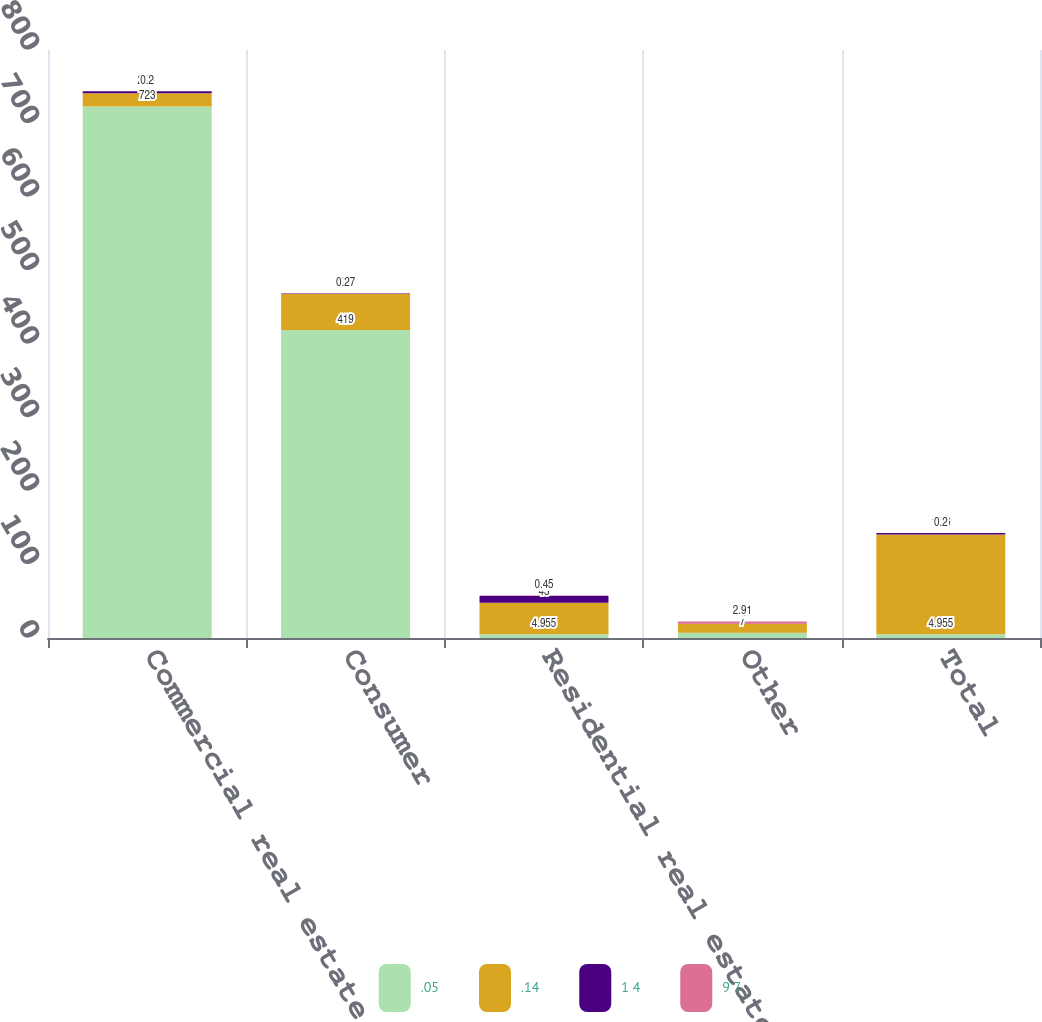Convert chart to OTSL. <chart><loc_0><loc_0><loc_500><loc_500><stacked_bar_chart><ecel><fcel>Commercial real estate<fcel>Consumer<fcel>Residential real estate<fcel>Other<fcel>Total<nl><fcel>.05<fcel>723<fcel>419<fcel>4.955<fcel>7<fcel>4.955<nl><fcel>.14<fcel>18<fcel>49<fcel>43<fcel>12<fcel>136<nl><fcel>1 4<fcel>2.81<fcel>0.8<fcel>9.32<fcel>0.37<fcel>1.86<nl><fcel>9 7<fcel>0.2<fcel>0.27<fcel>0.45<fcel>2.91<fcel>0.2<nl></chart> 